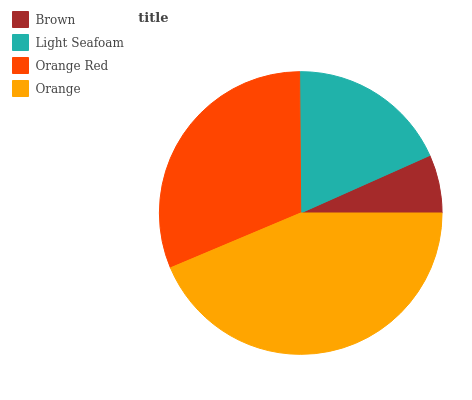Is Brown the minimum?
Answer yes or no. Yes. Is Orange the maximum?
Answer yes or no. Yes. Is Light Seafoam the minimum?
Answer yes or no. No. Is Light Seafoam the maximum?
Answer yes or no. No. Is Light Seafoam greater than Brown?
Answer yes or no. Yes. Is Brown less than Light Seafoam?
Answer yes or no. Yes. Is Brown greater than Light Seafoam?
Answer yes or no. No. Is Light Seafoam less than Brown?
Answer yes or no. No. Is Orange Red the high median?
Answer yes or no. Yes. Is Light Seafoam the low median?
Answer yes or no. Yes. Is Orange the high median?
Answer yes or no. No. Is Orange Red the low median?
Answer yes or no. No. 